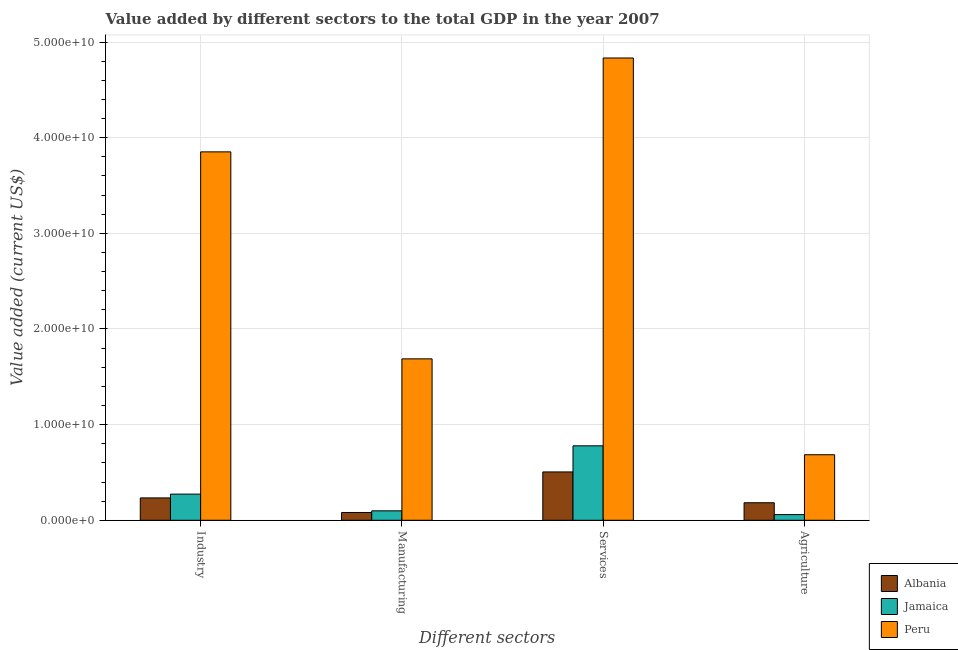Are the number of bars per tick equal to the number of legend labels?
Provide a short and direct response. Yes. Are the number of bars on each tick of the X-axis equal?
Ensure brevity in your answer.  Yes. What is the label of the 3rd group of bars from the left?
Ensure brevity in your answer.  Services. What is the value added by manufacturing sector in Albania?
Ensure brevity in your answer.  8.15e+08. Across all countries, what is the maximum value added by services sector?
Ensure brevity in your answer.  4.83e+1. Across all countries, what is the minimum value added by manufacturing sector?
Keep it short and to the point. 8.15e+08. In which country was the value added by services sector minimum?
Provide a succinct answer. Albania. What is the total value added by industrial sector in the graph?
Offer a terse response. 4.36e+1. What is the difference between the value added by services sector in Albania and that in Peru?
Your answer should be compact. -4.33e+1. What is the difference between the value added by industrial sector in Albania and the value added by agricultural sector in Peru?
Give a very brief answer. -4.51e+09. What is the average value added by manufacturing sector per country?
Provide a succinct answer. 6.23e+09. What is the difference between the value added by industrial sector and value added by services sector in Jamaica?
Offer a terse response. -5.05e+09. What is the ratio of the value added by agricultural sector in Peru to that in Jamaica?
Offer a terse response. 11.57. Is the value added by agricultural sector in Jamaica less than that in Peru?
Keep it short and to the point. Yes. What is the difference between the highest and the second highest value added by manufacturing sector?
Your answer should be very brief. 1.59e+1. What is the difference between the highest and the lowest value added by services sector?
Keep it short and to the point. 4.33e+1. Is the sum of the value added by manufacturing sector in Peru and Albania greater than the maximum value added by agricultural sector across all countries?
Provide a succinct answer. Yes. Is it the case that in every country, the sum of the value added by services sector and value added by agricultural sector is greater than the sum of value added by industrial sector and value added by manufacturing sector?
Offer a very short reply. No. What does the 2nd bar from the left in Agriculture represents?
Ensure brevity in your answer.  Jamaica. What does the 3rd bar from the right in Agriculture represents?
Make the answer very short. Albania. Is it the case that in every country, the sum of the value added by industrial sector and value added by manufacturing sector is greater than the value added by services sector?
Offer a terse response. No. How many bars are there?
Ensure brevity in your answer.  12. Are all the bars in the graph horizontal?
Provide a succinct answer. No. What is the difference between two consecutive major ticks on the Y-axis?
Your answer should be very brief. 1.00e+1. Are the values on the major ticks of Y-axis written in scientific E-notation?
Offer a very short reply. Yes. Does the graph contain any zero values?
Keep it short and to the point. No. Does the graph contain grids?
Provide a short and direct response. Yes. How many legend labels are there?
Your answer should be very brief. 3. What is the title of the graph?
Provide a succinct answer. Value added by different sectors to the total GDP in the year 2007. Does "Singapore" appear as one of the legend labels in the graph?
Your answer should be compact. No. What is the label or title of the X-axis?
Give a very brief answer. Different sectors. What is the label or title of the Y-axis?
Make the answer very short. Value added (current US$). What is the Value added (current US$) in Albania in Industry?
Make the answer very short. 2.34e+09. What is the Value added (current US$) of Jamaica in Industry?
Keep it short and to the point. 2.73e+09. What is the Value added (current US$) in Peru in Industry?
Give a very brief answer. 3.85e+1. What is the Value added (current US$) of Albania in Manufacturing?
Make the answer very short. 8.15e+08. What is the Value added (current US$) in Jamaica in Manufacturing?
Make the answer very short. 9.86e+08. What is the Value added (current US$) of Peru in Manufacturing?
Ensure brevity in your answer.  1.69e+1. What is the Value added (current US$) of Albania in Services?
Provide a short and direct response. 5.05e+09. What is the Value added (current US$) of Jamaica in Services?
Your answer should be very brief. 7.78e+09. What is the Value added (current US$) in Peru in Services?
Your answer should be very brief. 4.83e+1. What is the Value added (current US$) in Albania in Agriculture?
Give a very brief answer. 1.83e+09. What is the Value added (current US$) of Jamaica in Agriculture?
Your answer should be compact. 5.92e+08. What is the Value added (current US$) in Peru in Agriculture?
Keep it short and to the point. 6.85e+09. Across all Different sectors, what is the maximum Value added (current US$) in Albania?
Keep it short and to the point. 5.05e+09. Across all Different sectors, what is the maximum Value added (current US$) of Jamaica?
Your response must be concise. 7.78e+09. Across all Different sectors, what is the maximum Value added (current US$) of Peru?
Make the answer very short. 4.83e+1. Across all Different sectors, what is the minimum Value added (current US$) in Albania?
Your answer should be compact. 8.15e+08. Across all Different sectors, what is the minimum Value added (current US$) in Jamaica?
Your answer should be compact. 5.92e+08. Across all Different sectors, what is the minimum Value added (current US$) in Peru?
Your answer should be compact. 6.85e+09. What is the total Value added (current US$) in Albania in the graph?
Ensure brevity in your answer.  1.00e+1. What is the total Value added (current US$) in Jamaica in the graph?
Your response must be concise. 1.21e+1. What is the total Value added (current US$) of Peru in the graph?
Keep it short and to the point. 1.11e+11. What is the difference between the Value added (current US$) in Albania in Industry and that in Manufacturing?
Provide a short and direct response. 1.52e+09. What is the difference between the Value added (current US$) in Jamaica in Industry and that in Manufacturing?
Provide a succinct answer. 1.75e+09. What is the difference between the Value added (current US$) in Peru in Industry and that in Manufacturing?
Make the answer very short. 2.16e+1. What is the difference between the Value added (current US$) in Albania in Industry and that in Services?
Provide a short and direct response. -2.72e+09. What is the difference between the Value added (current US$) of Jamaica in Industry and that in Services?
Make the answer very short. -5.05e+09. What is the difference between the Value added (current US$) of Peru in Industry and that in Services?
Provide a short and direct response. -9.81e+09. What is the difference between the Value added (current US$) of Albania in Industry and that in Agriculture?
Provide a short and direct response. 5.04e+08. What is the difference between the Value added (current US$) in Jamaica in Industry and that in Agriculture?
Your response must be concise. 2.14e+09. What is the difference between the Value added (current US$) of Peru in Industry and that in Agriculture?
Offer a terse response. 3.17e+1. What is the difference between the Value added (current US$) in Albania in Manufacturing and that in Services?
Your response must be concise. -4.24e+09. What is the difference between the Value added (current US$) in Jamaica in Manufacturing and that in Services?
Your answer should be compact. -6.80e+09. What is the difference between the Value added (current US$) in Peru in Manufacturing and that in Services?
Keep it short and to the point. -3.15e+1. What is the difference between the Value added (current US$) of Albania in Manufacturing and that in Agriculture?
Make the answer very short. -1.02e+09. What is the difference between the Value added (current US$) in Jamaica in Manufacturing and that in Agriculture?
Offer a very short reply. 3.94e+08. What is the difference between the Value added (current US$) in Peru in Manufacturing and that in Agriculture?
Offer a very short reply. 1.00e+1. What is the difference between the Value added (current US$) in Albania in Services and that in Agriculture?
Provide a succinct answer. 3.22e+09. What is the difference between the Value added (current US$) in Jamaica in Services and that in Agriculture?
Offer a terse response. 7.19e+09. What is the difference between the Value added (current US$) in Peru in Services and that in Agriculture?
Your response must be concise. 4.15e+1. What is the difference between the Value added (current US$) of Albania in Industry and the Value added (current US$) of Jamaica in Manufacturing?
Your response must be concise. 1.35e+09. What is the difference between the Value added (current US$) of Albania in Industry and the Value added (current US$) of Peru in Manufacturing?
Provide a succinct answer. -1.45e+1. What is the difference between the Value added (current US$) in Jamaica in Industry and the Value added (current US$) in Peru in Manufacturing?
Offer a very short reply. -1.41e+1. What is the difference between the Value added (current US$) in Albania in Industry and the Value added (current US$) in Jamaica in Services?
Your answer should be compact. -5.45e+09. What is the difference between the Value added (current US$) of Albania in Industry and the Value added (current US$) of Peru in Services?
Ensure brevity in your answer.  -4.60e+1. What is the difference between the Value added (current US$) of Jamaica in Industry and the Value added (current US$) of Peru in Services?
Your response must be concise. -4.56e+1. What is the difference between the Value added (current US$) of Albania in Industry and the Value added (current US$) of Jamaica in Agriculture?
Offer a terse response. 1.74e+09. What is the difference between the Value added (current US$) in Albania in Industry and the Value added (current US$) in Peru in Agriculture?
Your answer should be compact. -4.51e+09. What is the difference between the Value added (current US$) in Jamaica in Industry and the Value added (current US$) in Peru in Agriculture?
Your answer should be compact. -4.12e+09. What is the difference between the Value added (current US$) in Albania in Manufacturing and the Value added (current US$) in Jamaica in Services?
Keep it short and to the point. -6.97e+09. What is the difference between the Value added (current US$) of Albania in Manufacturing and the Value added (current US$) of Peru in Services?
Provide a succinct answer. -4.75e+1. What is the difference between the Value added (current US$) of Jamaica in Manufacturing and the Value added (current US$) of Peru in Services?
Make the answer very short. -4.73e+1. What is the difference between the Value added (current US$) in Albania in Manufacturing and the Value added (current US$) in Jamaica in Agriculture?
Your answer should be compact. 2.23e+08. What is the difference between the Value added (current US$) of Albania in Manufacturing and the Value added (current US$) of Peru in Agriculture?
Provide a succinct answer. -6.04e+09. What is the difference between the Value added (current US$) in Jamaica in Manufacturing and the Value added (current US$) in Peru in Agriculture?
Give a very brief answer. -5.86e+09. What is the difference between the Value added (current US$) in Albania in Services and the Value added (current US$) in Jamaica in Agriculture?
Your response must be concise. 4.46e+09. What is the difference between the Value added (current US$) in Albania in Services and the Value added (current US$) in Peru in Agriculture?
Keep it short and to the point. -1.80e+09. What is the difference between the Value added (current US$) in Jamaica in Services and the Value added (current US$) in Peru in Agriculture?
Offer a terse response. 9.33e+08. What is the average Value added (current US$) of Albania per Different sectors?
Your response must be concise. 2.51e+09. What is the average Value added (current US$) in Jamaica per Different sectors?
Make the answer very short. 3.02e+09. What is the average Value added (current US$) in Peru per Different sectors?
Give a very brief answer. 2.76e+1. What is the difference between the Value added (current US$) in Albania and Value added (current US$) in Jamaica in Industry?
Your answer should be very brief. -3.97e+08. What is the difference between the Value added (current US$) of Albania and Value added (current US$) of Peru in Industry?
Make the answer very short. -3.62e+1. What is the difference between the Value added (current US$) of Jamaica and Value added (current US$) of Peru in Industry?
Provide a short and direct response. -3.58e+1. What is the difference between the Value added (current US$) of Albania and Value added (current US$) of Jamaica in Manufacturing?
Offer a terse response. -1.71e+08. What is the difference between the Value added (current US$) in Albania and Value added (current US$) in Peru in Manufacturing?
Your answer should be compact. -1.61e+1. What is the difference between the Value added (current US$) in Jamaica and Value added (current US$) in Peru in Manufacturing?
Your answer should be compact. -1.59e+1. What is the difference between the Value added (current US$) of Albania and Value added (current US$) of Jamaica in Services?
Give a very brief answer. -2.73e+09. What is the difference between the Value added (current US$) of Albania and Value added (current US$) of Peru in Services?
Offer a very short reply. -4.33e+1. What is the difference between the Value added (current US$) of Jamaica and Value added (current US$) of Peru in Services?
Keep it short and to the point. -4.05e+1. What is the difference between the Value added (current US$) in Albania and Value added (current US$) in Jamaica in Agriculture?
Provide a short and direct response. 1.24e+09. What is the difference between the Value added (current US$) of Albania and Value added (current US$) of Peru in Agriculture?
Your answer should be compact. -5.02e+09. What is the difference between the Value added (current US$) of Jamaica and Value added (current US$) of Peru in Agriculture?
Your response must be concise. -6.26e+09. What is the ratio of the Value added (current US$) of Albania in Industry to that in Manufacturing?
Offer a very short reply. 2.87. What is the ratio of the Value added (current US$) in Jamaica in Industry to that in Manufacturing?
Your answer should be compact. 2.77. What is the ratio of the Value added (current US$) of Peru in Industry to that in Manufacturing?
Give a very brief answer. 2.28. What is the ratio of the Value added (current US$) of Albania in Industry to that in Services?
Make the answer very short. 0.46. What is the ratio of the Value added (current US$) of Jamaica in Industry to that in Services?
Offer a terse response. 0.35. What is the ratio of the Value added (current US$) in Peru in Industry to that in Services?
Your answer should be compact. 0.8. What is the ratio of the Value added (current US$) of Albania in Industry to that in Agriculture?
Ensure brevity in your answer.  1.27. What is the ratio of the Value added (current US$) in Jamaica in Industry to that in Agriculture?
Your answer should be very brief. 4.62. What is the ratio of the Value added (current US$) of Peru in Industry to that in Agriculture?
Offer a terse response. 5.62. What is the ratio of the Value added (current US$) of Albania in Manufacturing to that in Services?
Provide a short and direct response. 0.16. What is the ratio of the Value added (current US$) of Jamaica in Manufacturing to that in Services?
Keep it short and to the point. 0.13. What is the ratio of the Value added (current US$) in Peru in Manufacturing to that in Services?
Your answer should be very brief. 0.35. What is the ratio of the Value added (current US$) in Albania in Manufacturing to that in Agriculture?
Your response must be concise. 0.44. What is the ratio of the Value added (current US$) in Jamaica in Manufacturing to that in Agriculture?
Keep it short and to the point. 1.67. What is the ratio of the Value added (current US$) of Peru in Manufacturing to that in Agriculture?
Give a very brief answer. 2.46. What is the ratio of the Value added (current US$) of Albania in Services to that in Agriculture?
Make the answer very short. 2.76. What is the ratio of the Value added (current US$) of Jamaica in Services to that in Agriculture?
Make the answer very short. 13.15. What is the ratio of the Value added (current US$) of Peru in Services to that in Agriculture?
Offer a terse response. 7.05. What is the difference between the highest and the second highest Value added (current US$) of Albania?
Your response must be concise. 2.72e+09. What is the difference between the highest and the second highest Value added (current US$) of Jamaica?
Keep it short and to the point. 5.05e+09. What is the difference between the highest and the second highest Value added (current US$) of Peru?
Give a very brief answer. 9.81e+09. What is the difference between the highest and the lowest Value added (current US$) of Albania?
Keep it short and to the point. 4.24e+09. What is the difference between the highest and the lowest Value added (current US$) in Jamaica?
Your answer should be very brief. 7.19e+09. What is the difference between the highest and the lowest Value added (current US$) of Peru?
Offer a terse response. 4.15e+1. 